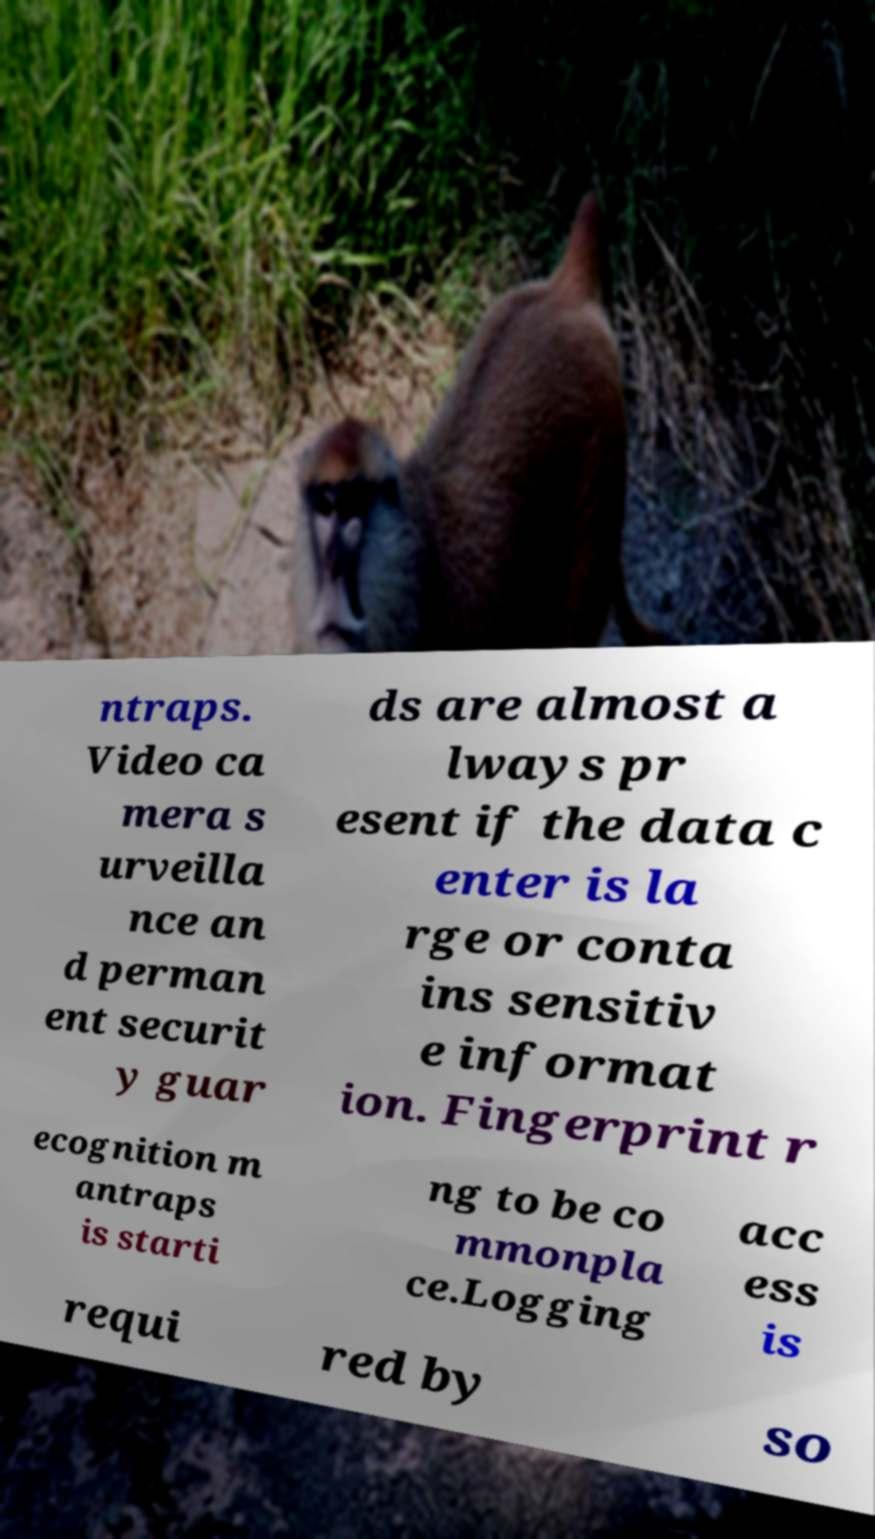Could you assist in decoding the text presented in this image and type it out clearly? ntraps. Video ca mera s urveilla nce an d perman ent securit y guar ds are almost a lways pr esent if the data c enter is la rge or conta ins sensitiv e informat ion. Fingerprint r ecognition m antraps is starti ng to be co mmonpla ce.Logging acc ess is requi red by so 